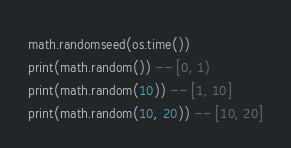<code> <loc_0><loc_0><loc_500><loc_500><_Lua_>math.randomseed(os.time())
print(math.random()) -- [0, 1)
print(math.random(10)) -- [1, 10]
print(math.random(10, 20)) -- [10, 20]
</code> 